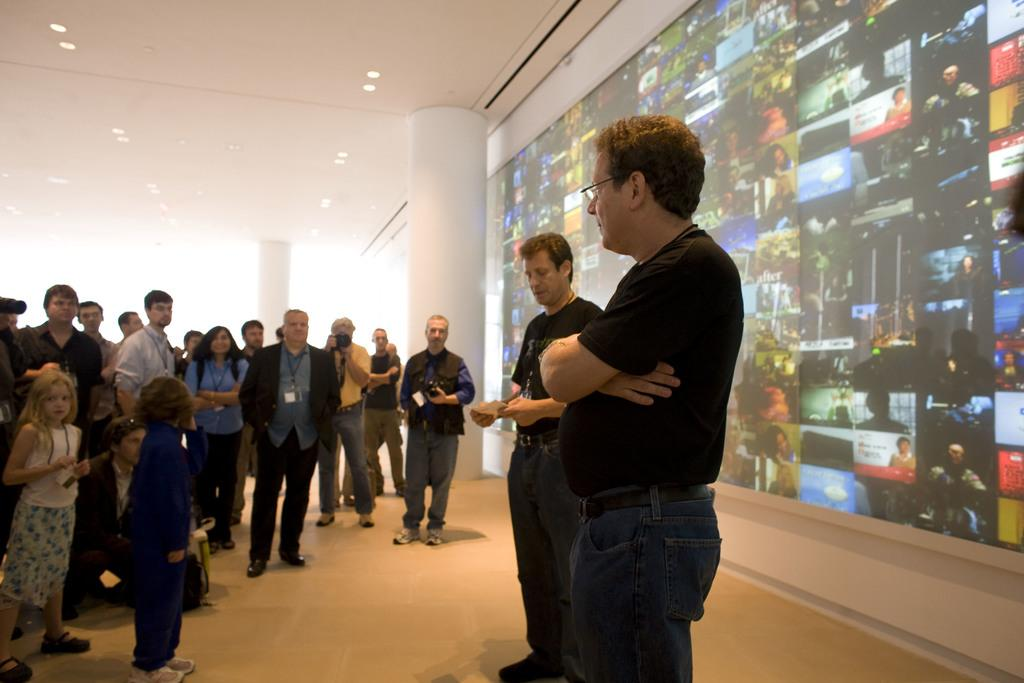What is happening in the image? There are people standing in the image. What can be seen in the background of the image? There are pillars and boards in the background of the image. What is visible at the top of the image? There are lights visible at the top of the image. What type of cast can be seen on the floor in the image? There is no cast present on the floor in the image. 